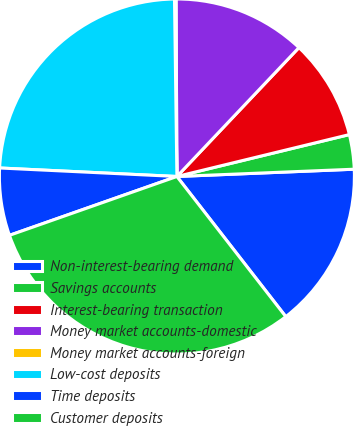<chart> <loc_0><loc_0><loc_500><loc_500><pie_chart><fcel>Non-interest-bearing demand<fcel>Savings accounts<fcel>Interest-bearing transaction<fcel>Money market accounts-domestic<fcel>Money market accounts-foreign<fcel>Low-cost deposits<fcel>Time deposits<fcel>Customer deposits<nl><fcel>15.14%<fcel>3.14%<fcel>9.14%<fcel>12.14%<fcel>0.14%<fcel>24.02%<fcel>6.14%<fcel>30.13%<nl></chart> 